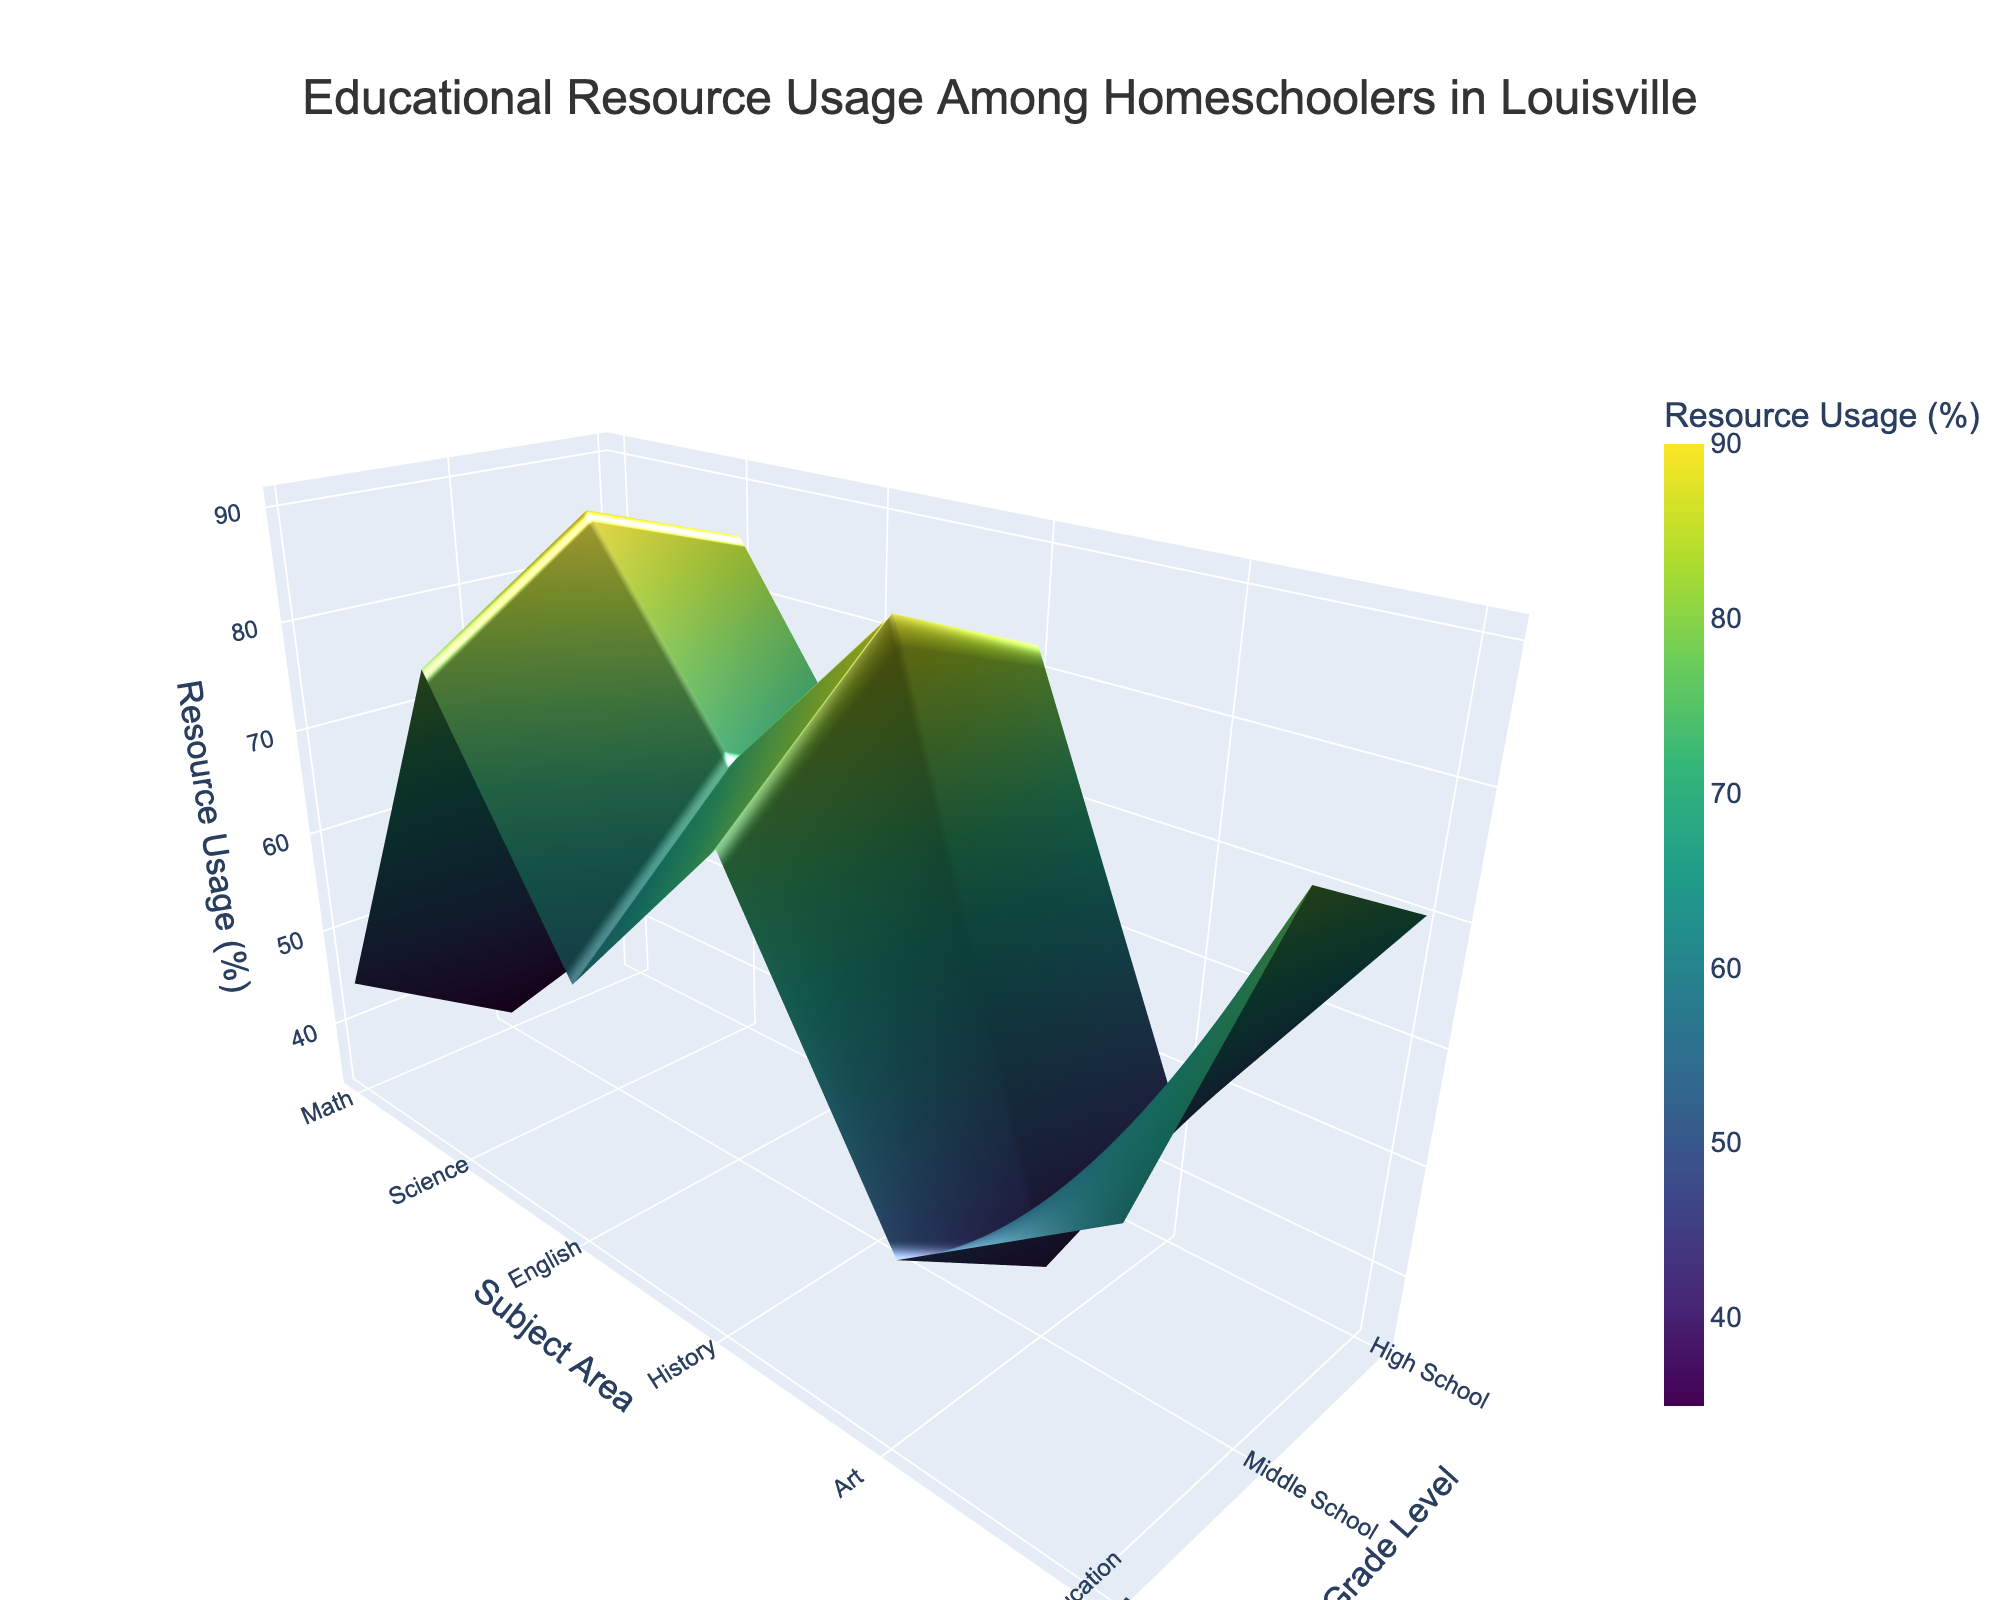What's the title of the figure? The title is usually at the top of the plot and provides a summary of what the plot represents. In this case, it should describe the overall content.
Answer: Educational Resource Usage Among Homeschoolers in Louisville What are the axes titles in the figure? The axes titles label the dimensions of the plot and tell you what each axis represents. You can see these titles along each axis in the 3D plot.
Answer: Subject Area, Grade Level, Resource Usage (%) Which subject in high school has the highest resource usage? To find the subject with the highest resource usage in high school, look for the highest point in the high school section of the plot along the vertical axis.
Answer: English How does resource usage in Art change from elementary to high school? Observe the 3D surface plot for the Art subject area and track the vertical values (resource usage) across different grade levels from elementary to high school.
Answer: It decreases Which grade level and subject combination has the lowest resource usage? Identify the point on the plot with the lowest vertical value and note the corresponding grade level and subject area.
Answer: High School Art What is the average resource usage for Math across all grade levels? To find the average, add the resource usage percentages for Math across all grade levels and divide by the number of grade levels. This involves summing the values (75 + 82 + 88) and dividing by 3.
Answer: 81.67% Compare the resource usage for Science between middle school and high school. Look at the Science subject area for both middle school and high school and compare the vertical values (representation of resource usage) for each.
Answer: Middle school: 70%, High school: 78% Which subject shows the most consistent usage across all grade levels? Examine the variance in vertical heights for each subject area across different grade levels. The subject with the least variation in height is the most consistent.
Answer: Physical Education What is the difference in resource usage for English between elementary and middle school? Subtract the resource usage percentage for English in elementary school from that in middle school (85% - 80%).
Answer: 5% Which subject shows the largest drop in resource usage from elementary to high school? Compare the drop in resource usage from elementary to high school for each subject. The subject with the largest difference in values will be the answer (Art: 45% - 35%).
Answer: Art 